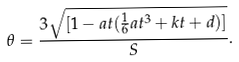<formula> <loc_0><loc_0><loc_500><loc_500>\theta = \frac { 3 \sqrt { [ 1 - a t ( \frac { 1 } { 6 } a t ^ { 3 } + k t + d ) ] } } { S } .</formula> 